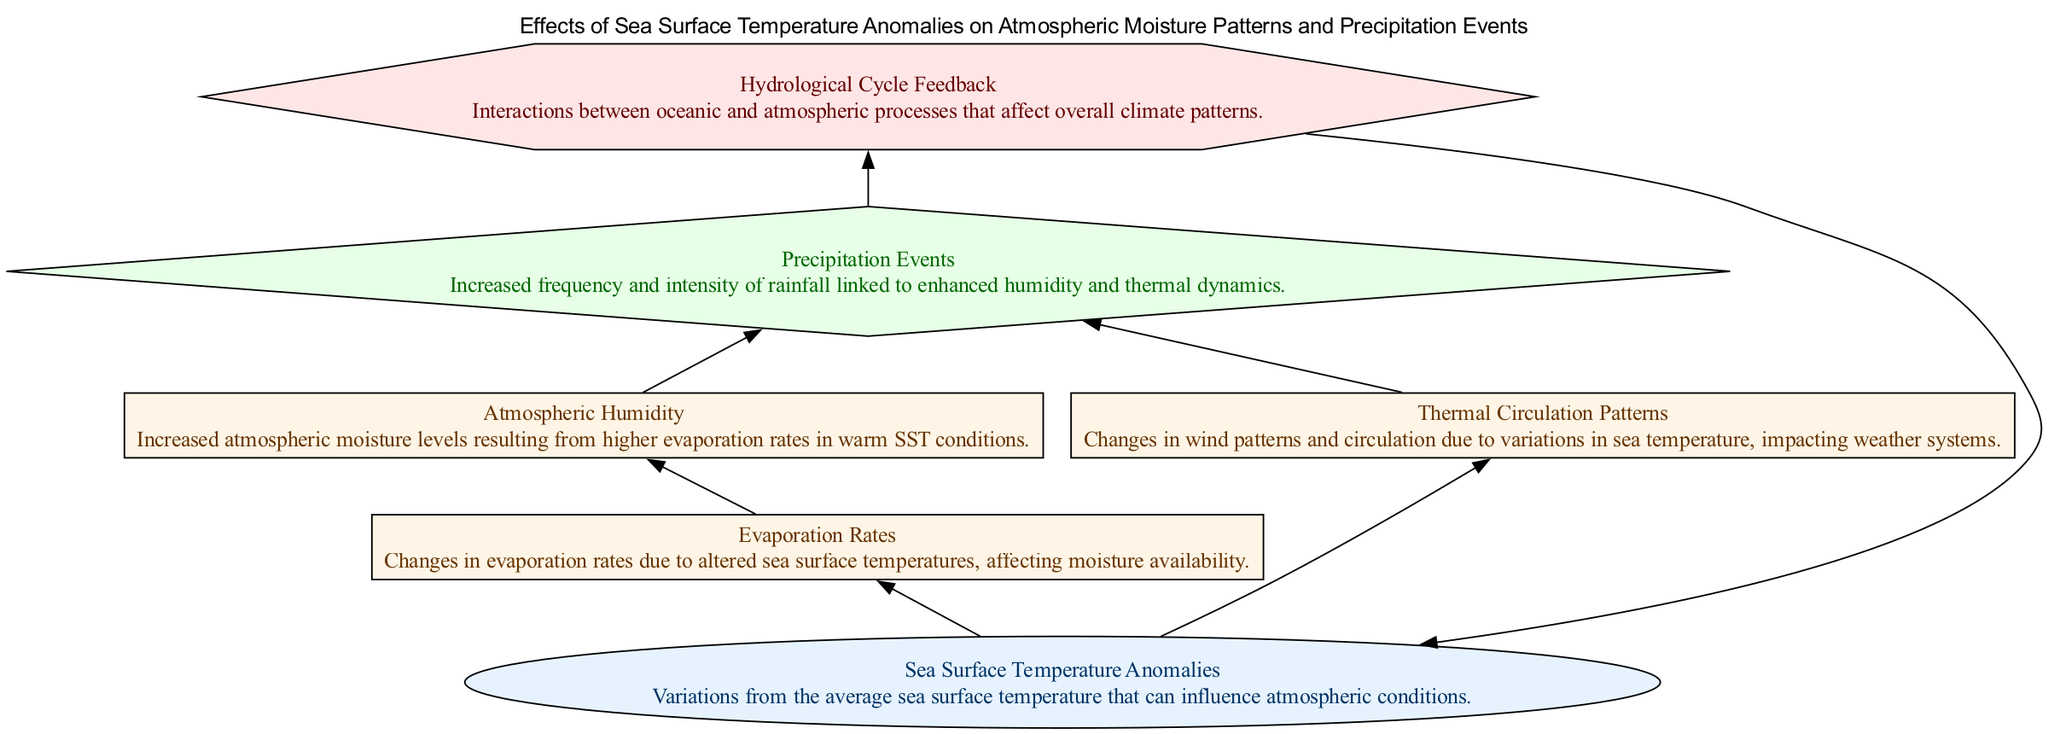What is the input node in the diagram? The input node is labeled "Sea Surface Temperature Anomalies," which initiates the flow of processes in the diagram.
Answer: Sea Surface Temperature Anomalies How many edges are connected to the "Evaporation Rates" node? The "Evaporation Rates" node has one incoming edge from "Sea Surface Temperature Anomalies" and one outgoing edge to "Atmospheric Humidity," resulting in a total of two edges connected to it.
Answer: 2 What does the "Hydrological Cycle Feedback" node influence? The "Hydrological Cycle Feedback" node influences the "Sea Surface Temperature Anomalies" node, creating a feedback loop in the diagram.
Answer: Sea Surface Temperature Anomalies Which Process node comes after "Atmospheric Humidity"? The "Precipitation Events" node comes directly after "Atmospheric Humidity," indicating the sequence of processes.
Answer: Precipitation Events What relationship exists between "Thermal Circulation Patterns" and "Precipitation Events"? "Thermal Circulation Patterns" has a direct influence on "Precipitation Events," suggesting that changes in wind patterns and circulation affect precipitation levels.
Answer: Direct influence Describe the overall flow from the "Sea Surface Temperature Anomalies" node to the output. The flow starts at "Sea Surface Temperature Anomalies," moves to "Evaporation Rates," then to "Atmospheric Humidity," which leads to "Precipitation Events," making a clear path to the output.
Answer: Sea Surface Temperature Anomalies → Evaporation Rates → Atmospheric Humidity → Precipitation Events How many Process nodes are there in total? There are four Process nodes in the diagram: "Evaporation Rates," "Atmospheric Humidity," "Thermal Circulation Patterns," and "Precipitation Events."
Answer: 4 What is the category of the "Precipitation Events" node? The "Precipitation Events" node is categorized as an Output, meaning it is the result of the preceding processes in the flow.
Answer: Output Which type of node influences "Precipitation Events" besides "Atmospheric Humidity"? Besides "Atmospheric Humidity," the "Thermal Circulation Patterns" node also influences "Precipitation Events," indicating that both humidity and circulation dynamics are important for precipitation.
Answer: Thermal Circulation Patterns What are the categories of the nodes related to "Sea Surface Temperature Anomalies"? The nodes related to "Sea Surface Temperature Anomalies" include one Input node (itself), two Process nodes ("Evaporation Rates" and "Thermal Circulation Patterns"), one Output node ("Precipitation Events"), and one Feedback node ("Hydrological Cycle Feedback").
Answer: Input, Process, Output, Feedback 